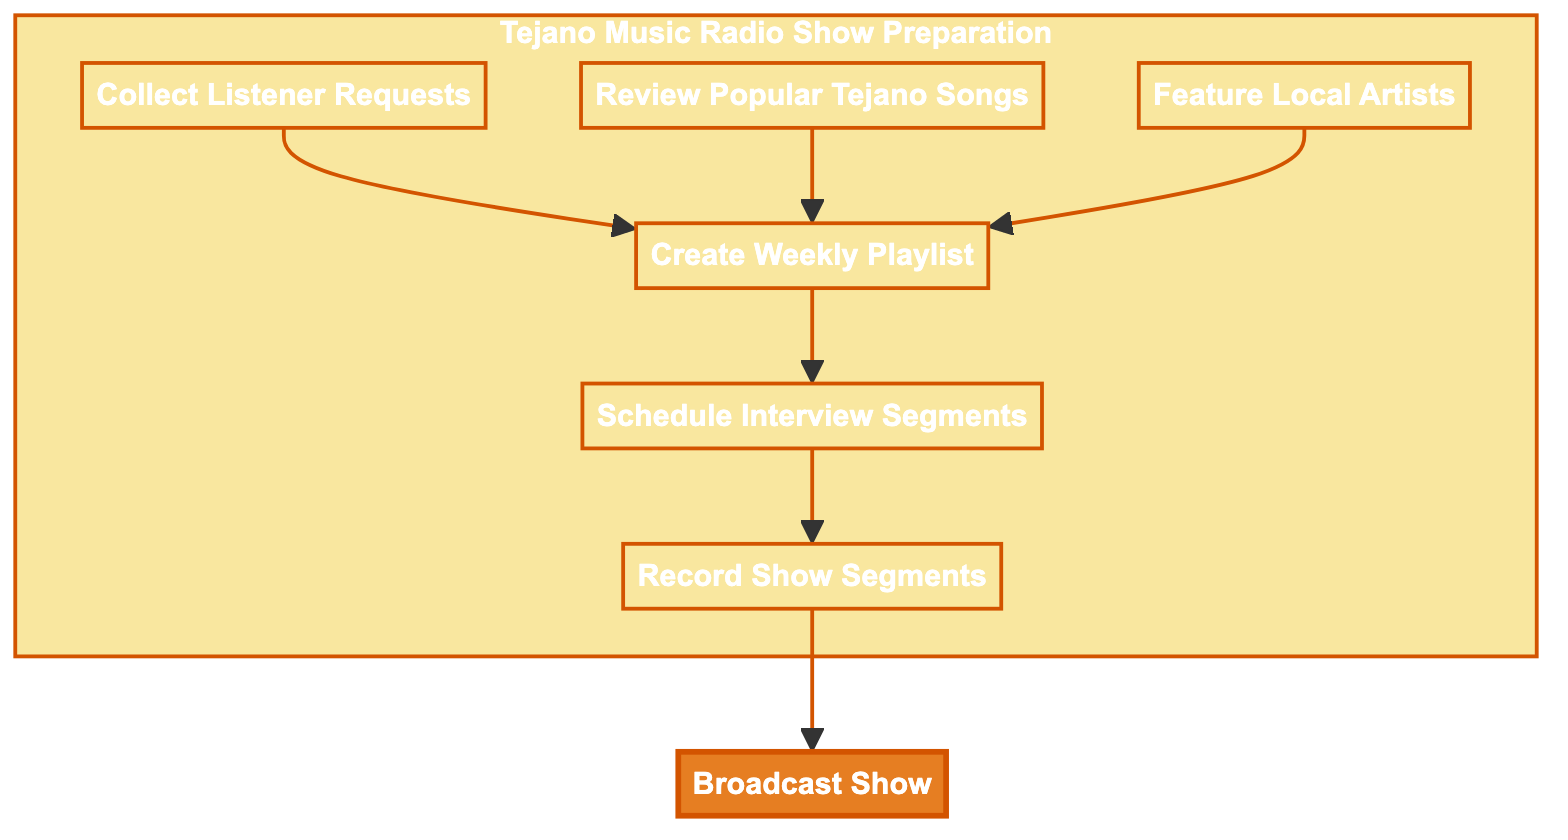What is the last step in the Tejano music playlist creation process? The final step is to broadcast the show, which includes airing the playlist along with interviews and listener shout-outs. This can be seen as the endpoint of the flowchart where all previous steps feed into it.
Answer: Broadcast Show How many main activities are involved before broadcasting the show? There are six main activities leading up to the broadcast. They are collecting listener requests, reviewing popular Tejano songs, featuring local artists, creating a weekly playlist, scheduling interview segments, and recording show segments. Counting these elements gives a total of six.
Answer: 6 Which element comes right before creating the weekly playlist? The three elements that feed into creating the weekly playlist are collecting listener requests, reviewing popular Tejano songs, and featuring local artists. Thus, the answer can be one of these three, and since all three contribute to creating the weekly playlist, it depends on which one is considered first. However, there is no specific order indicated between them.
Answer: Collect Listener Requests, Review Popular Tejano Songs, Feature Local Artists What is the purpose of scheduling interview segments? The purpose of scheduling interview segments is to plan interviews with the featured artists for the upcoming show. This is highlighted as a specific activity that supports the overall process of preparing for the broadcast.
Answer: Plan interviews with featured artists What three processes directly feed into the creation of the weekly playlist? The three processes are collecting listener requests, reviewing popular Tejano songs, and featuring local artists. Each of these contributes unique elements to the compilation of the weekly playlist.
Answer: Collect Listener Requests, Review Popular Tejano Songs, Feature Local Artists Which process is classified under the "Tejano Music Radio Show Preparation" subgraph? All activities leading up to the broadcast of the show are part of the "Tejano Music Radio Show Preparation" subgraph including collecting listener requests, reviewing popular Tejano songs, and others leading up to the creation of the playlist.
Answer: Collect Listener Requests, Review Popular Tejano Songs, Feature Local Artists, Create Weekly Playlist, Schedule Interview Segments, Record Show Segments Which activity involves listeners directly? The activity that involves listeners directly is collecting listener requests. This is the point where the show engages with the audience to gather their song preferences.
Answer: Collect Listener Requests What is the function of recording show segments? The function of recording show segments is to create the necessary content for the radio show, including the intro, segues, and commentary around each song in the playlist. It's crucial for a seamless presentation on air.
Answer: Record intro, segues, and commentary 